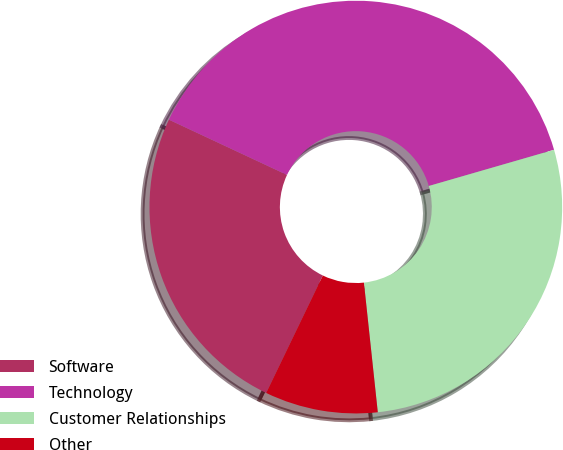Convert chart to OTSL. <chart><loc_0><loc_0><loc_500><loc_500><pie_chart><fcel>Software<fcel>Technology<fcel>Customer Relationships<fcel>Other<nl><fcel>24.81%<fcel>38.56%<fcel>27.78%<fcel>8.85%<nl></chart> 